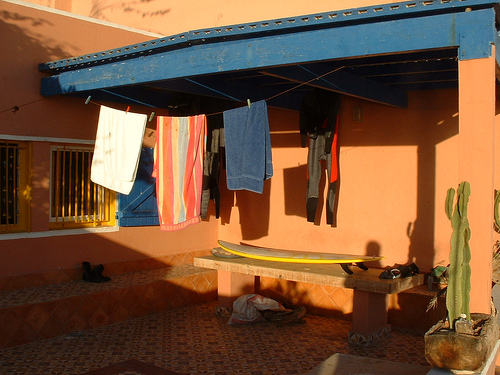<image>
Is the building behind the towel? No. The building is not behind the towel. From this viewpoint, the building appears to be positioned elsewhere in the scene. 